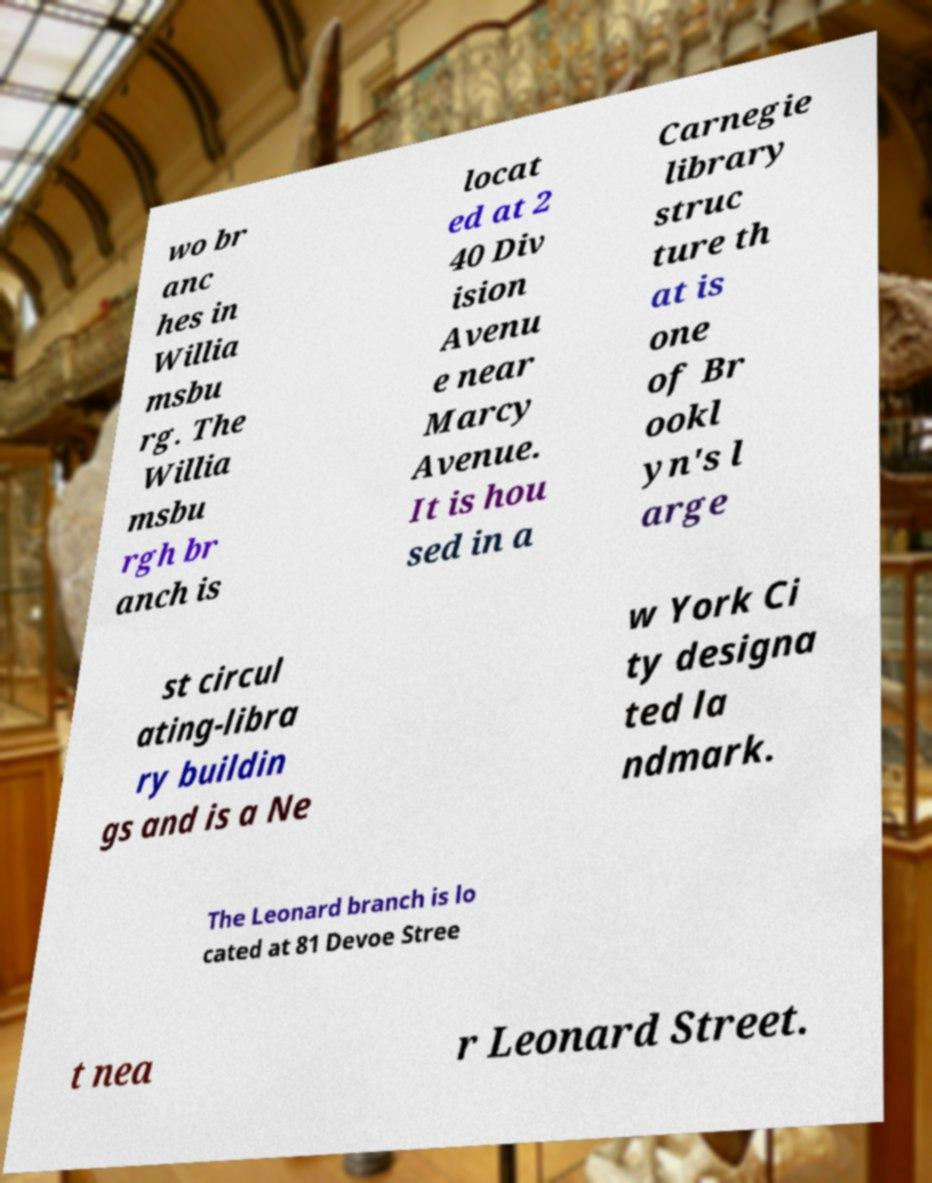There's text embedded in this image that I need extracted. Can you transcribe it verbatim? wo br anc hes in Willia msbu rg. The Willia msbu rgh br anch is locat ed at 2 40 Div ision Avenu e near Marcy Avenue. It is hou sed in a Carnegie library struc ture th at is one of Br ookl yn's l arge st circul ating-libra ry buildin gs and is a Ne w York Ci ty designa ted la ndmark. The Leonard branch is lo cated at 81 Devoe Stree t nea r Leonard Street. 